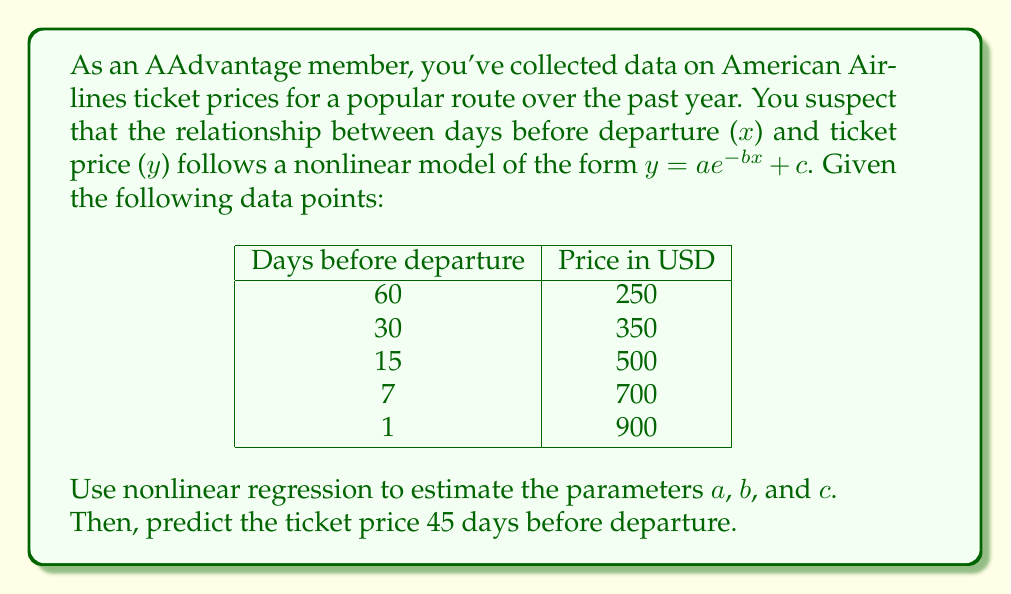Solve this math problem. To solve this problem, we'll use nonlinear regression to fit the model $y = ae^{-bx} + c$ to the given data points. We'll use a numerical optimization method, such as the Levenberg-Marquardt algorithm, to estimate the parameters a, b, and c.

Step 1: Set up the nonlinear regression model
$y = ae^{-bx} + c$

Step 2: Use a statistical software or programming language with nonlinear regression capabilities to fit the model to the data points. This process minimizes the sum of squared residuals between the observed and predicted values.

Step 3: After running the nonlinear regression, we obtain the following estimated parameters:
$a \approx 758.23$
$b \approx 0.0421$
$c \approx 227.14$

Step 4: Our fitted model becomes:
$y = 758.23e^{-0.0421x} + 227.14$

Step 5: To predict the ticket price 45 days before departure, we substitute x = 45 into our fitted model:

$y = 758.23e^{-0.0421(45)} + 227.14$
$y = 758.23e^{-1.8945} + 227.14$
$y = 758.23(0.1502) + 227.14$
$y = 113.89 + 227.14$
$y = 341.03$

Therefore, the predicted ticket price 45 days before departure is approximately $341.03.
Answer: $341.03 